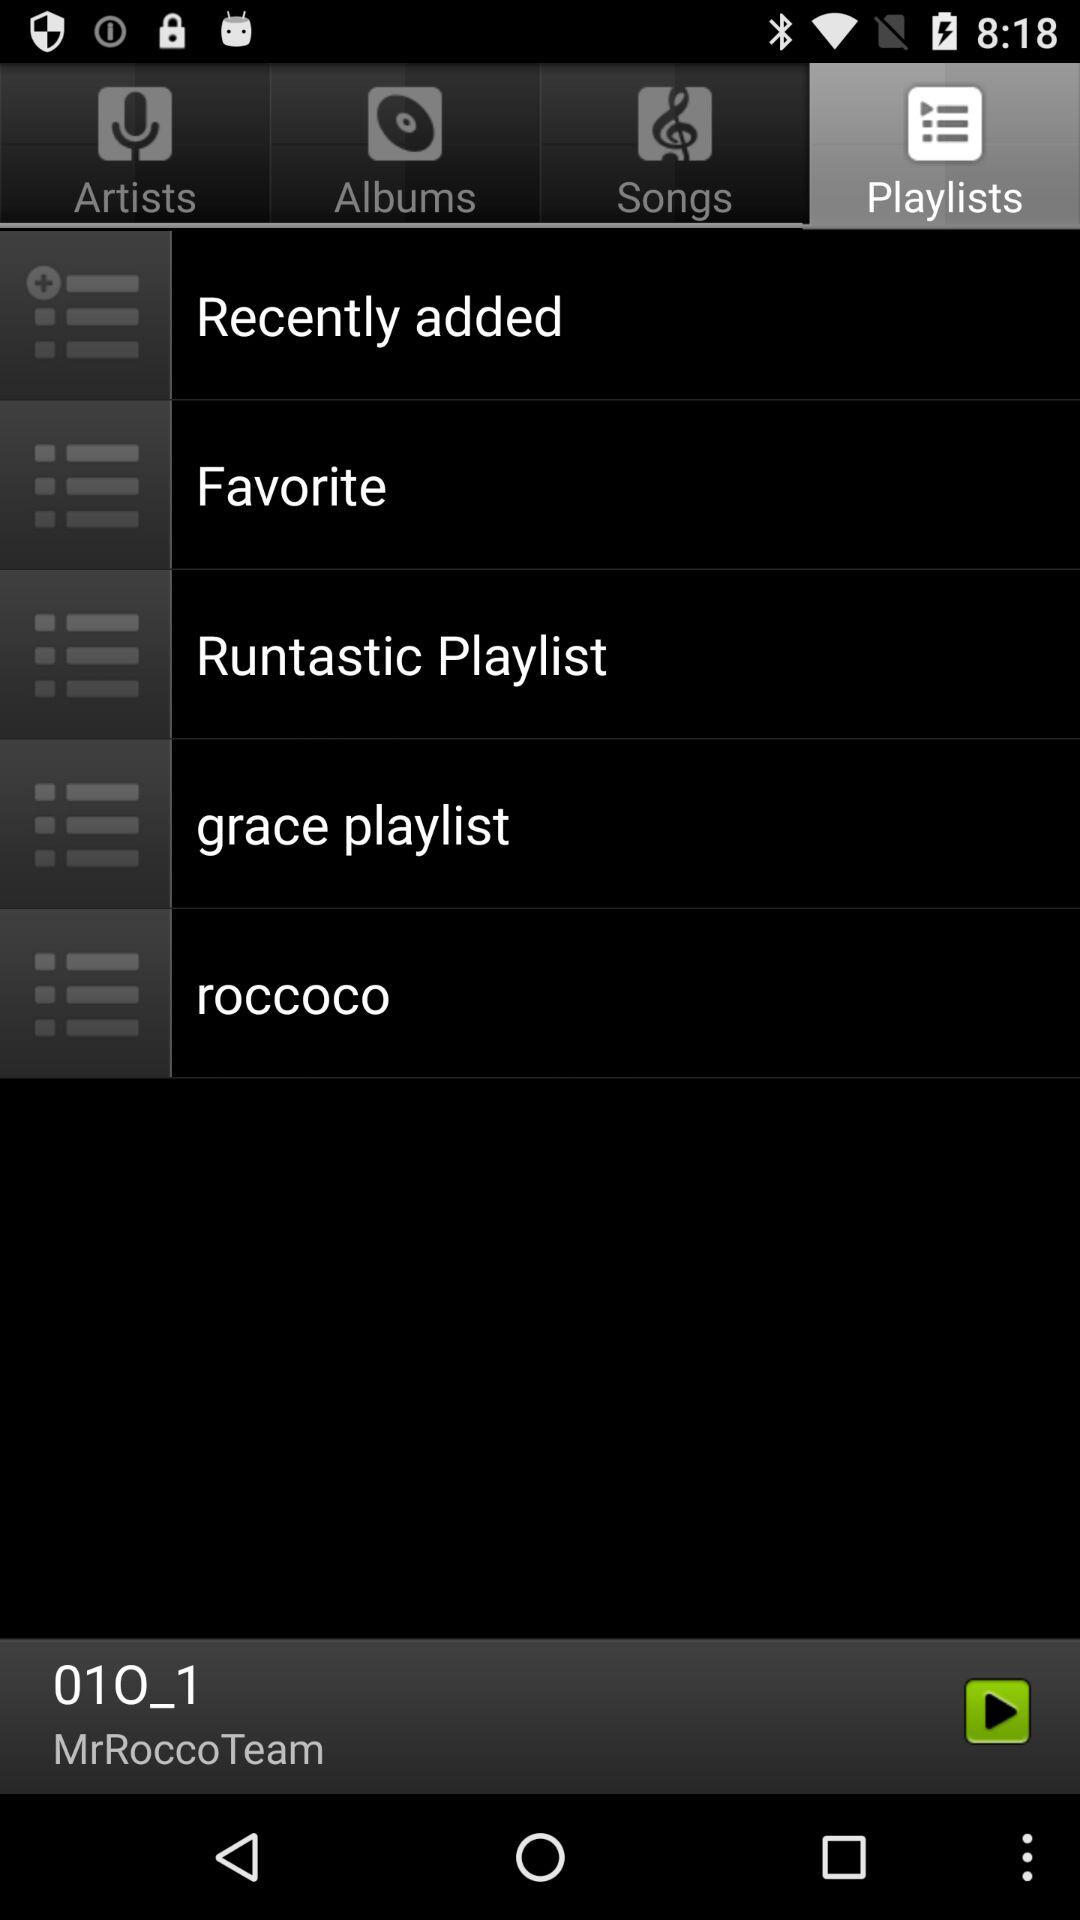Which tab is selected? The selected tab is "Playlists". 